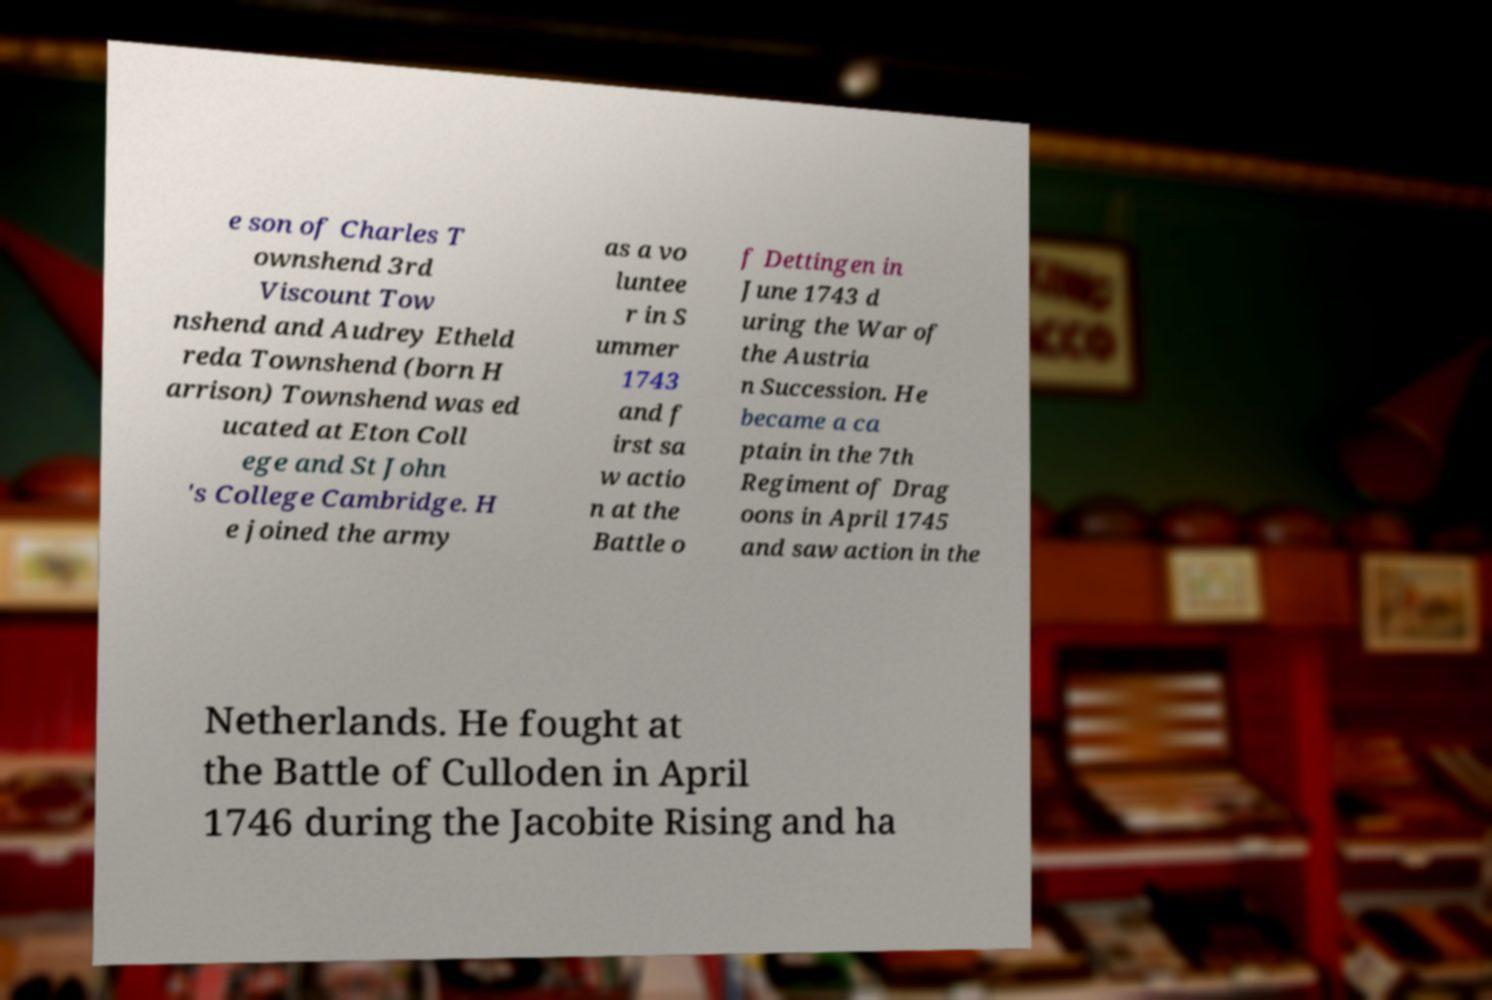Can you read and provide the text displayed in the image?This photo seems to have some interesting text. Can you extract and type it out for me? e son of Charles T ownshend 3rd Viscount Tow nshend and Audrey Etheld reda Townshend (born H arrison) Townshend was ed ucated at Eton Coll ege and St John 's College Cambridge. H e joined the army as a vo luntee r in S ummer 1743 and f irst sa w actio n at the Battle o f Dettingen in June 1743 d uring the War of the Austria n Succession. He became a ca ptain in the 7th Regiment of Drag oons in April 1745 and saw action in the Netherlands. He fought at the Battle of Culloden in April 1746 during the Jacobite Rising and ha 